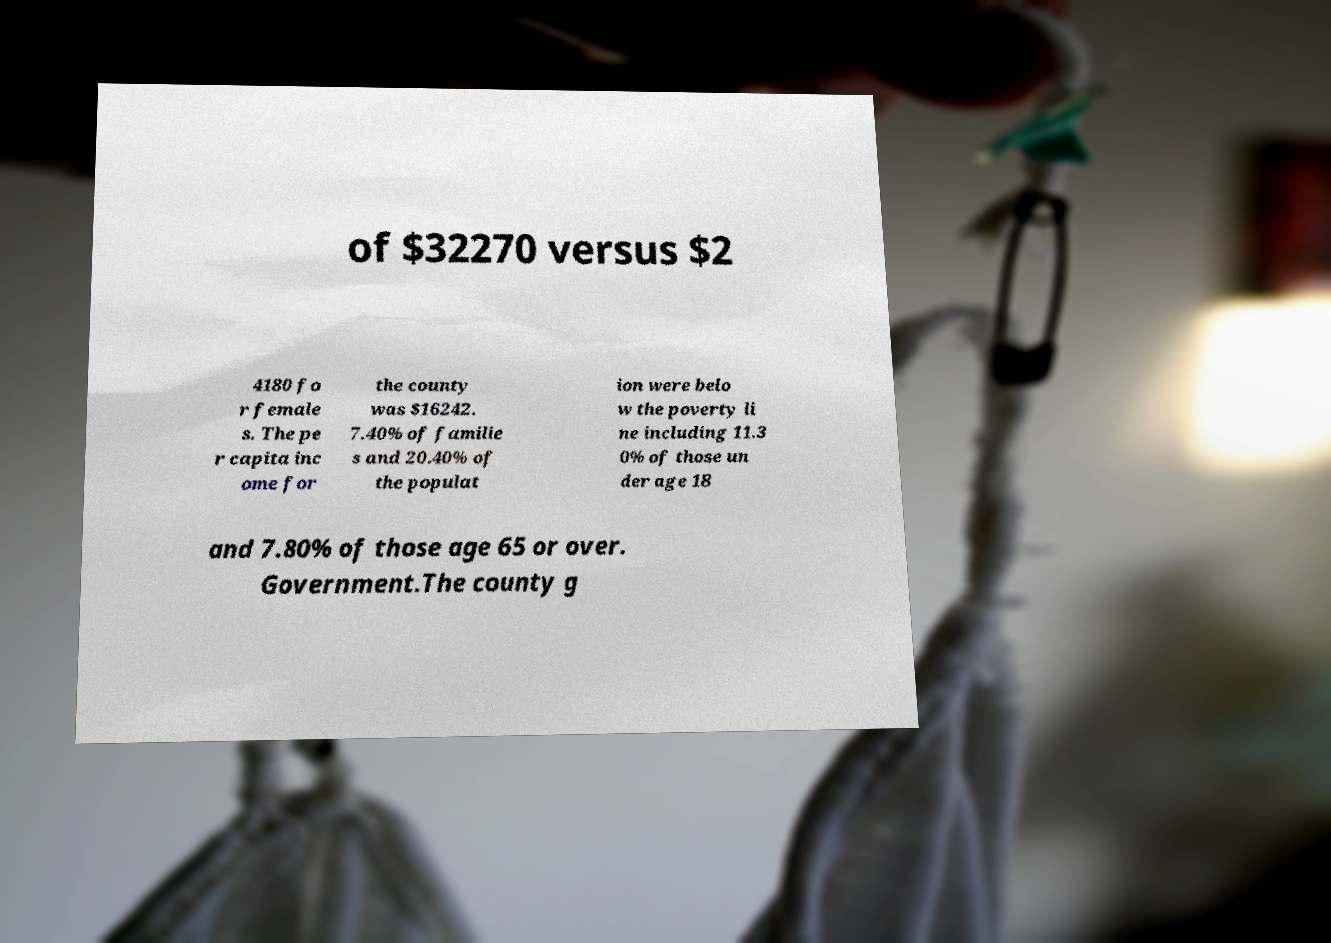Could you assist in decoding the text presented in this image and type it out clearly? of $32270 versus $2 4180 fo r female s. The pe r capita inc ome for the county was $16242. 7.40% of familie s and 20.40% of the populat ion were belo w the poverty li ne including 11.3 0% of those un der age 18 and 7.80% of those age 65 or over. Government.The county g 